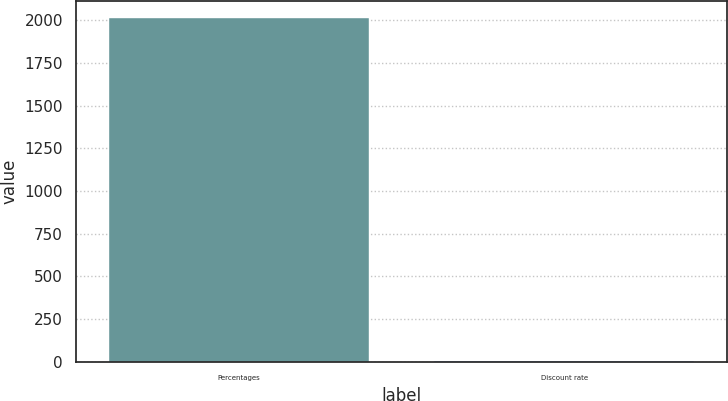<chart> <loc_0><loc_0><loc_500><loc_500><bar_chart><fcel>Percentages<fcel>Discount rate<nl><fcel>2012<fcel>3.67<nl></chart> 